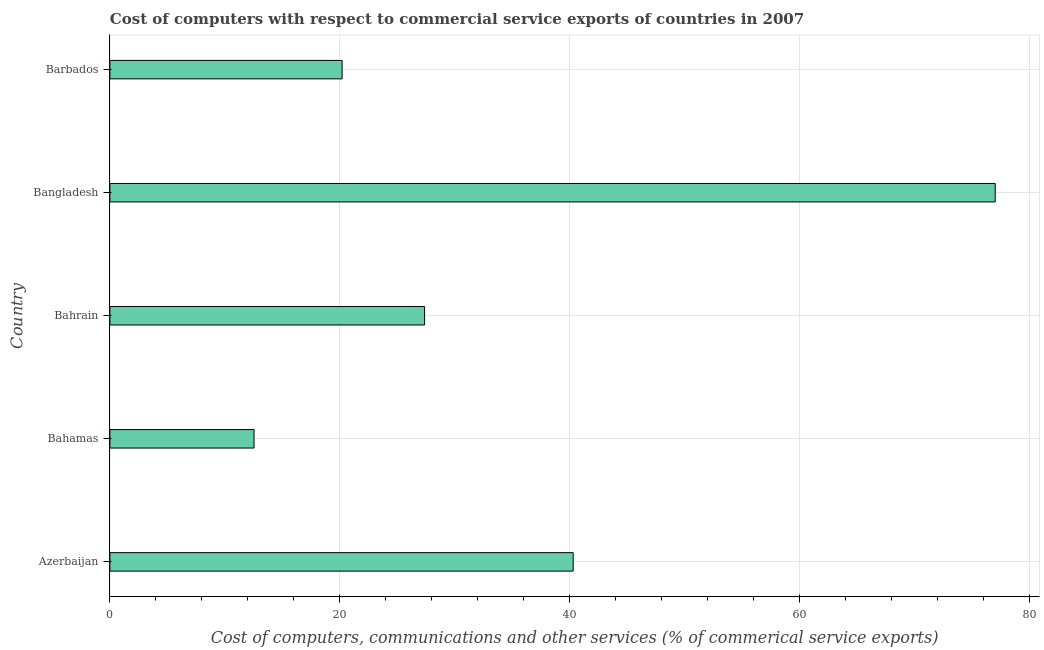Does the graph contain any zero values?
Ensure brevity in your answer.  No. What is the title of the graph?
Make the answer very short. Cost of computers with respect to commercial service exports of countries in 2007. What is the label or title of the X-axis?
Your response must be concise. Cost of computers, communications and other services (% of commerical service exports). What is the cost of communications in Bangladesh?
Keep it short and to the point. 77. Across all countries, what is the maximum cost of communications?
Offer a very short reply. 77. Across all countries, what is the minimum  computer and other services?
Offer a terse response. 12.54. In which country was the cost of communications maximum?
Your answer should be very brief. Bangladesh. In which country was the  computer and other services minimum?
Your answer should be compact. Bahamas. What is the sum of the cost of communications?
Your response must be concise. 177.39. What is the difference between the cost of communications in Bahamas and Bangladesh?
Provide a short and direct response. -64.46. What is the average cost of communications per country?
Provide a succinct answer. 35.48. What is the median  computer and other services?
Ensure brevity in your answer.  27.37. What is the ratio of the  computer and other services in Azerbaijan to that in Bahrain?
Keep it short and to the point. 1.47. Is the difference between the  computer and other services in Bahrain and Barbados greater than the difference between any two countries?
Make the answer very short. No. What is the difference between the highest and the second highest  computer and other services?
Your response must be concise. 36.7. Is the sum of the cost of communications in Azerbaijan and Bahrain greater than the maximum cost of communications across all countries?
Offer a very short reply. No. What is the difference between the highest and the lowest cost of communications?
Provide a short and direct response. 64.46. How many countries are there in the graph?
Your answer should be very brief. 5. What is the Cost of computers, communications and other services (% of commerical service exports) in Azerbaijan?
Make the answer very short. 40.29. What is the Cost of computers, communications and other services (% of commerical service exports) of Bahamas?
Your answer should be compact. 12.54. What is the Cost of computers, communications and other services (% of commerical service exports) of Bahrain?
Your answer should be very brief. 27.37. What is the Cost of computers, communications and other services (% of commerical service exports) of Bangladesh?
Provide a short and direct response. 77. What is the Cost of computers, communications and other services (% of commerical service exports) of Barbados?
Your answer should be very brief. 20.2. What is the difference between the Cost of computers, communications and other services (% of commerical service exports) in Azerbaijan and Bahamas?
Ensure brevity in your answer.  27.76. What is the difference between the Cost of computers, communications and other services (% of commerical service exports) in Azerbaijan and Bahrain?
Offer a very short reply. 12.92. What is the difference between the Cost of computers, communications and other services (% of commerical service exports) in Azerbaijan and Bangladesh?
Make the answer very short. -36.7. What is the difference between the Cost of computers, communications and other services (% of commerical service exports) in Azerbaijan and Barbados?
Make the answer very short. 20.1. What is the difference between the Cost of computers, communications and other services (% of commerical service exports) in Bahamas and Bahrain?
Make the answer very short. -14.83. What is the difference between the Cost of computers, communications and other services (% of commerical service exports) in Bahamas and Bangladesh?
Your answer should be compact. -64.46. What is the difference between the Cost of computers, communications and other services (% of commerical service exports) in Bahamas and Barbados?
Ensure brevity in your answer.  -7.66. What is the difference between the Cost of computers, communications and other services (% of commerical service exports) in Bahrain and Bangladesh?
Your answer should be compact. -49.63. What is the difference between the Cost of computers, communications and other services (% of commerical service exports) in Bahrain and Barbados?
Ensure brevity in your answer.  7.17. What is the difference between the Cost of computers, communications and other services (% of commerical service exports) in Bangladesh and Barbados?
Your response must be concise. 56.8. What is the ratio of the Cost of computers, communications and other services (% of commerical service exports) in Azerbaijan to that in Bahamas?
Provide a short and direct response. 3.21. What is the ratio of the Cost of computers, communications and other services (% of commerical service exports) in Azerbaijan to that in Bahrain?
Your answer should be very brief. 1.47. What is the ratio of the Cost of computers, communications and other services (% of commerical service exports) in Azerbaijan to that in Bangladesh?
Give a very brief answer. 0.52. What is the ratio of the Cost of computers, communications and other services (% of commerical service exports) in Azerbaijan to that in Barbados?
Provide a succinct answer. 2. What is the ratio of the Cost of computers, communications and other services (% of commerical service exports) in Bahamas to that in Bahrain?
Give a very brief answer. 0.46. What is the ratio of the Cost of computers, communications and other services (% of commerical service exports) in Bahamas to that in Bangladesh?
Give a very brief answer. 0.16. What is the ratio of the Cost of computers, communications and other services (% of commerical service exports) in Bahamas to that in Barbados?
Your response must be concise. 0.62. What is the ratio of the Cost of computers, communications and other services (% of commerical service exports) in Bahrain to that in Bangladesh?
Offer a very short reply. 0.35. What is the ratio of the Cost of computers, communications and other services (% of commerical service exports) in Bahrain to that in Barbados?
Keep it short and to the point. 1.35. What is the ratio of the Cost of computers, communications and other services (% of commerical service exports) in Bangladesh to that in Barbados?
Ensure brevity in your answer.  3.81. 